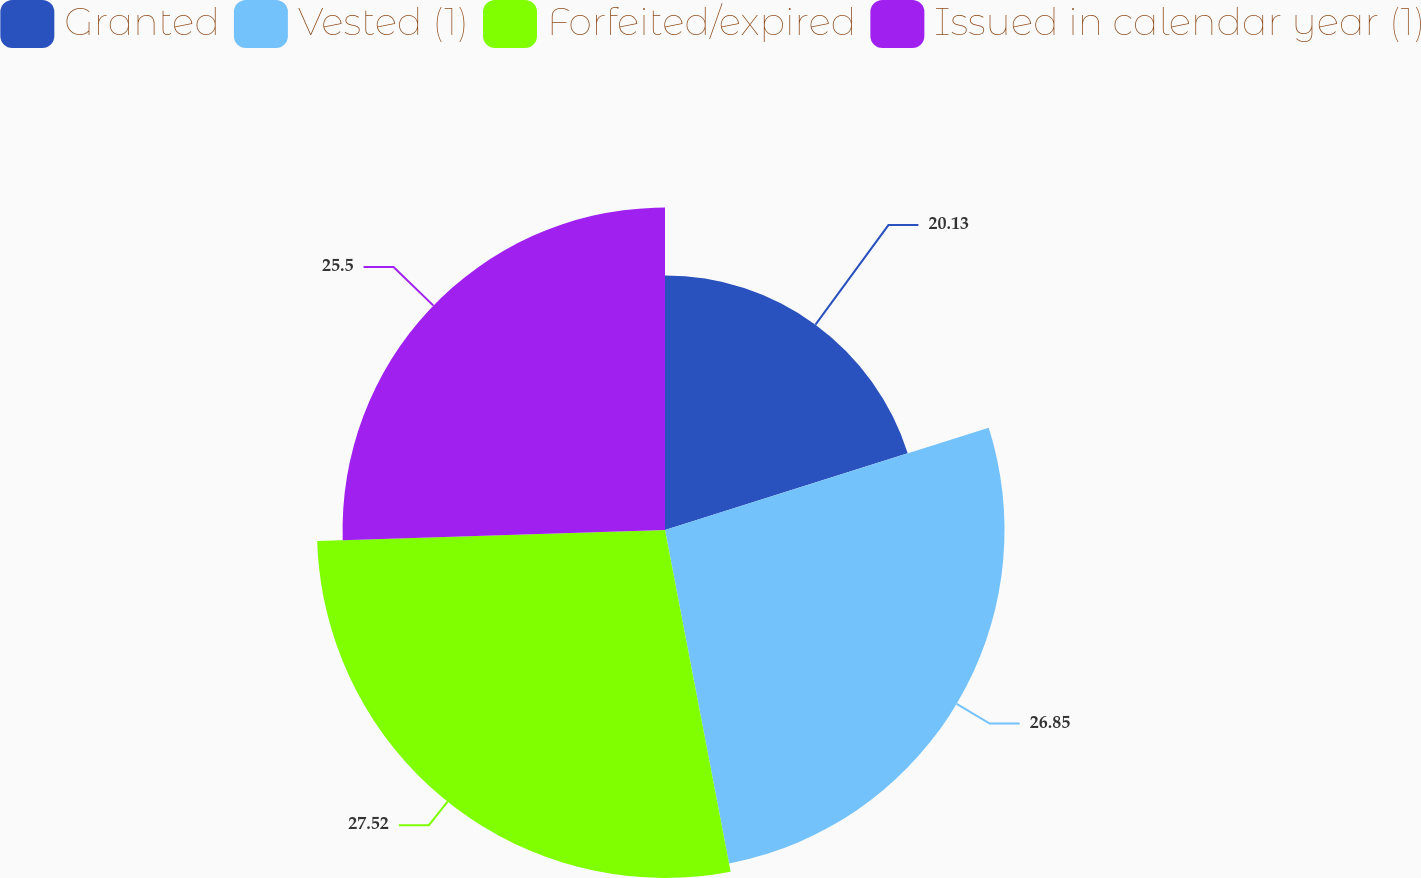<chart> <loc_0><loc_0><loc_500><loc_500><pie_chart><fcel>Granted<fcel>Vested (1)<fcel>Forfeited/expired<fcel>Issued in calendar year (1)<nl><fcel>20.13%<fcel>26.85%<fcel>27.52%<fcel>25.5%<nl></chart> 